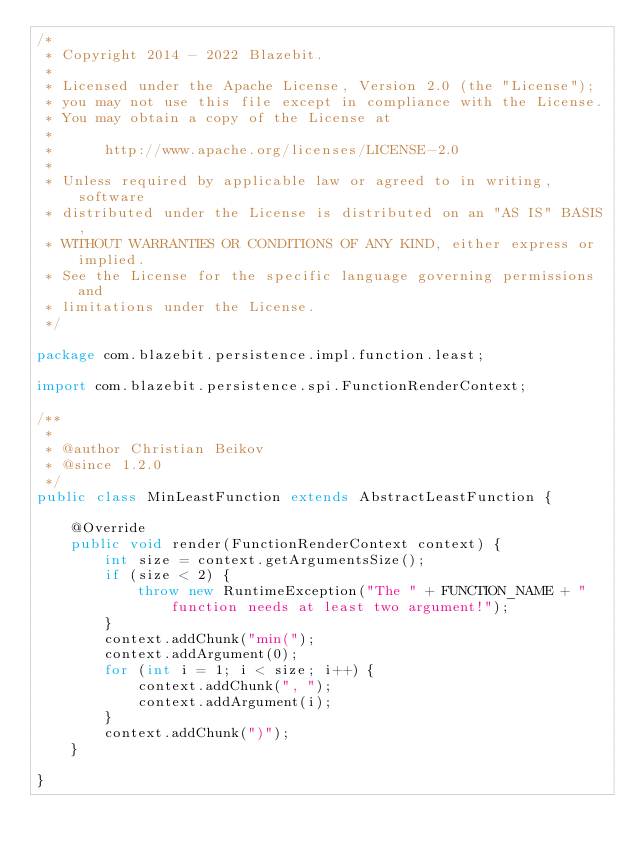<code> <loc_0><loc_0><loc_500><loc_500><_Java_>/*
 * Copyright 2014 - 2022 Blazebit.
 *
 * Licensed under the Apache License, Version 2.0 (the "License");
 * you may not use this file except in compliance with the License.
 * You may obtain a copy of the License at
 *
 *      http://www.apache.org/licenses/LICENSE-2.0
 *
 * Unless required by applicable law or agreed to in writing, software
 * distributed under the License is distributed on an "AS IS" BASIS,
 * WITHOUT WARRANTIES OR CONDITIONS OF ANY KIND, either express or implied.
 * See the License for the specific language governing permissions and
 * limitations under the License.
 */

package com.blazebit.persistence.impl.function.least;

import com.blazebit.persistence.spi.FunctionRenderContext;

/**
 *
 * @author Christian Beikov
 * @since 1.2.0
 */
public class MinLeastFunction extends AbstractLeastFunction {

    @Override
    public void render(FunctionRenderContext context) {
        int size = context.getArgumentsSize();
        if (size < 2) {
            throw new RuntimeException("The " + FUNCTION_NAME + " function needs at least two argument!");
        }
        context.addChunk("min(");
        context.addArgument(0);
        for (int i = 1; i < size; i++) {
            context.addChunk(", ");
            context.addArgument(i);
        }
        context.addChunk(")");
    }

}
</code> 